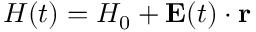<formula> <loc_0><loc_0><loc_500><loc_500>{ H } ( t ) = H _ { 0 } + E ( t ) \cdot r</formula> 